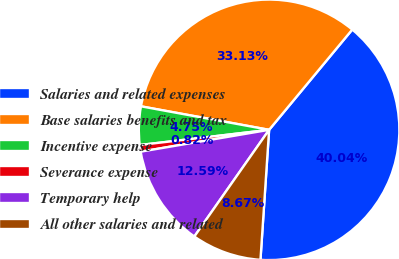Convert chart to OTSL. <chart><loc_0><loc_0><loc_500><loc_500><pie_chart><fcel>Salaries and related expenses<fcel>Base salaries benefits and tax<fcel>Incentive expense<fcel>Severance expense<fcel>Temporary help<fcel>All other salaries and related<nl><fcel>40.04%<fcel>33.13%<fcel>4.75%<fcel>0.82%<fcel>12.59%<fcel>8.67%<nl></chart> 